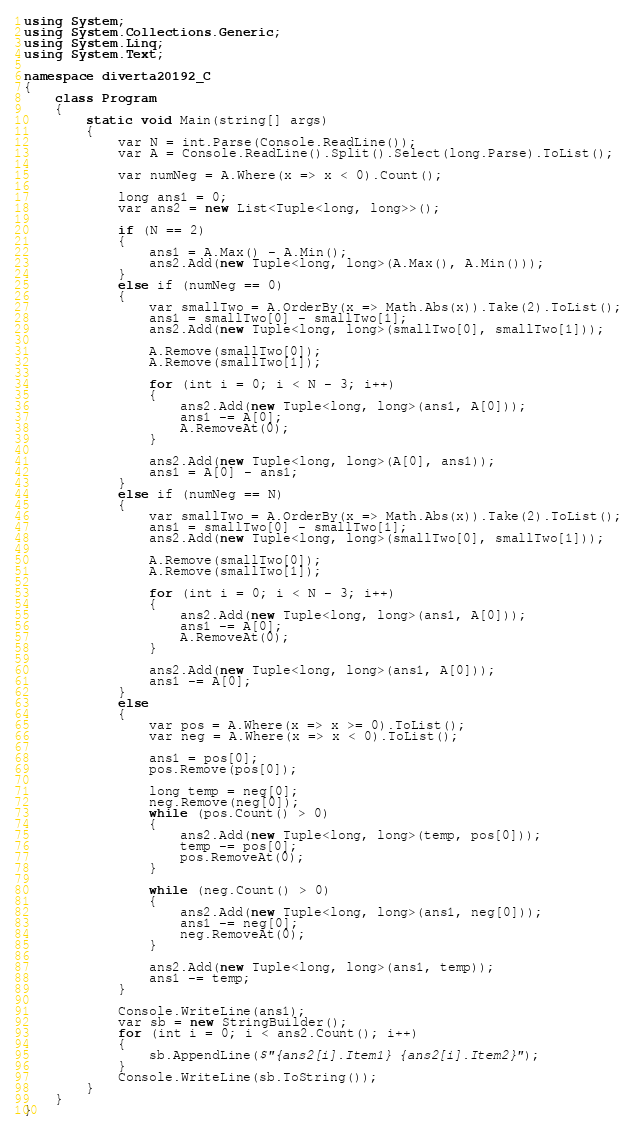Convert code to text. <code><loc_0><loc_0><loc_500><loc_500><_C#_>using System;
using System.Collections.Generic;
using System.Linq;
using System.Text;

namespace diverta20192_C
{
    class Program
    {
        static void Main(string[] args)
        {
            var N = int.Parse(Console.ReadLine());
            var A = Console.ReadLine().Split().Select(long.Parse).ToList();

            var numNeg = A.Where(x => x < 0).Count();

            long ans1 = 0;
            var ans2 = new List<Tuple<long, long>>();

            if (N == 2)
            {
                ans1 = A.Max() - A.Min();
                ans2.Add(new Tuple<long, long>(A.Max(), A.Min()));
            }
            else if (numNeg == 0)
            {
                var smallTwo = A.OrderBy(x => Math.Abs(x)).Take(2).ToList();
                ans1 = smallTwo[0] - smallTwo[1];
                ans2.Add(new Tuple<long, long>(smallTwo[0], smallTwo[1]));

                A.Remove(smallTwo[0]);
                A.Remove(smallTwo[1]);

                for (int i = 0; i < N - 3; i++)
                {
                    ans2.Add(new Tuple<long, long>(ans1, A[0]));
                    ans1 -= A[0];
                    A.RemoveAt(0);
                }

                ans2.Add(new Tuple<long, long>(A[0], ans1));
                ans1 = A[0] - ans1;
            }
            else if (numNeg == N)
            {
                var smallTwo = A.OrderBy(x => Math.Abs(x)).Take(2).ToList();
                ans1 = smallTwo[0] - smallTwo[1];
                ans2.Add(new Tuple<long, long>(smallTwo[0], smallTwo[1]));

                A.Remove(smallTwo[0]);
                A.Remove(smallTwo[1]);

                for (int i = 0; i < N - 3; i++)
                {
                    ans2.Add(new Tuple<long, long>(ans1, A[0]));
                    ans1 -= A[0];
                    A.RemoveAt(0);
                }

                ans2.Add(new Tuple<long, long>(ans1, A[0]));
                ans1 -= A[0];
            }
            else
            {
                var pos = A.Where(x => x >= 0).ToList();
                var neg = A.Where(x => x < 0).ToList();

                ans1 = pos[0];
                pos.Remove(pos[0]);

                long temp = neg[0];
                neg.Remove(neg[0]);
                while (pos.Count() > 0)
                {
                    ans2.Add(new Tuple<long, long>(temp, pos[0]));
                    temp -= pos[0];
                    pos.RemoveAt(0);
                }

                while (neg.Count() > 0)
                {
                    ans2.Add(new Tuple<long, long>(ans1, neg[0]));
                    ans1 -= neg[0];
                    neg.RemoveAt(0);
                }

                ans2.Add(new Tuple<long, long>(ans1, temp));
                ans1 -= temp;
            }

            Console.WriteLine(ans1);
            var sb = new StringBuilder();
            for (int i = 0; i < ans2.Count(); i++)
            {
                sb.AppendLine($"{ans2[i].Item1} {ans2[i].Item2}");
            }
            Console.WriteLine(sb.ToString());
        }
    }
}
</code> 